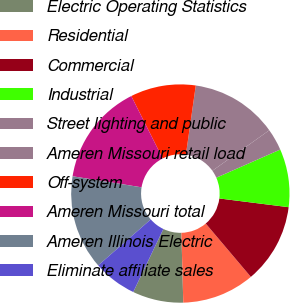<chart> <loc_0><loc_0><loc_500><loc_500><pie_chart><fcel>Electric Operating Statistics<fcel>Residential<fcel>Commercial<fcel>Industrial<fcel>Street lighting and public<fcel>Ameren Missouri retail load<fcel>Off-system<fcel>Ameren Missouri total<fcel>Ameren Illinois Electric<fcel>Eliminate affiliate sales<nl><fcel>7.53%<fcel>10.75%<fcel>11.83%<fcel>8.6%<fcel>3.24%<fcel>12.9%<fcel>9.68%<fcel>15.05%<fcel>13.97%<fcel>6.46%<nl></chart> 